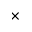Convert formula to latex. <formula><loc_0><loc_0><loc_500><loc_500>\times</formula> 